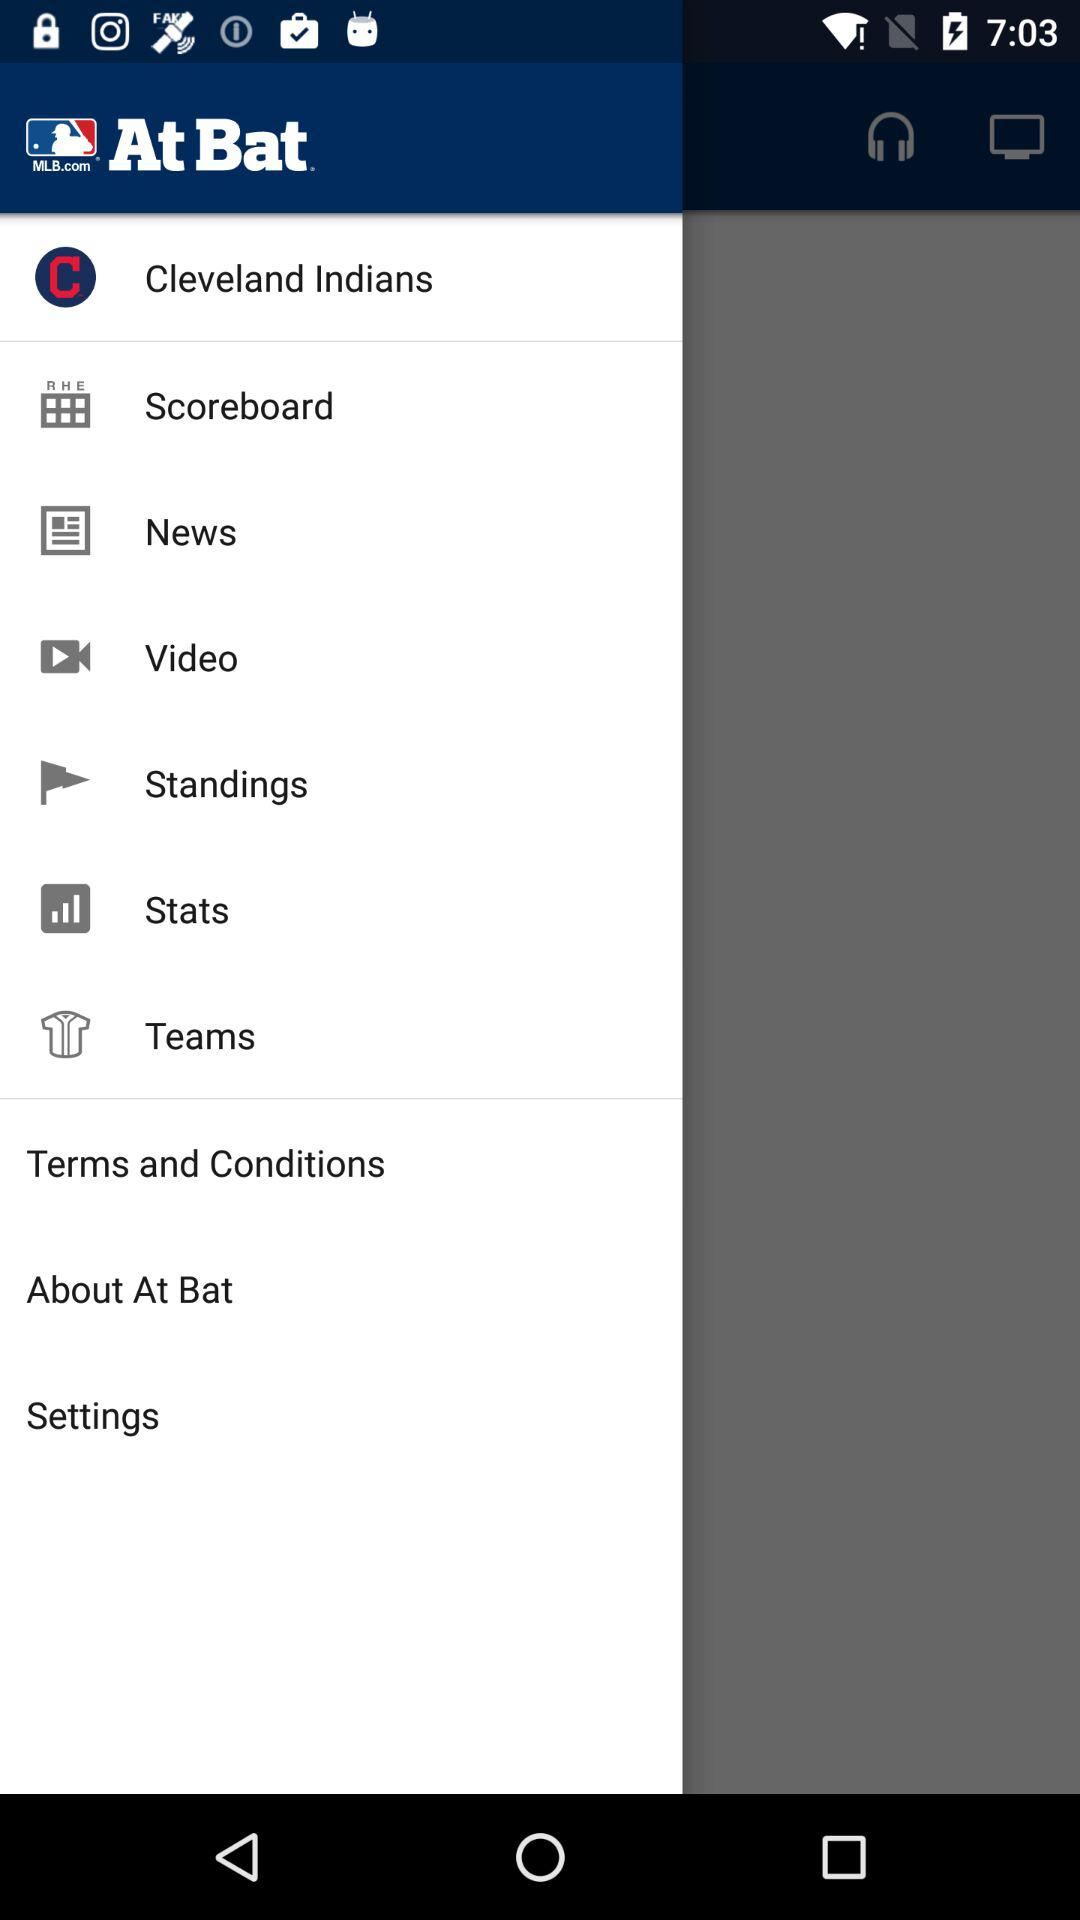What is the name of the application? The name of the application is "MLB.com At Bat". 